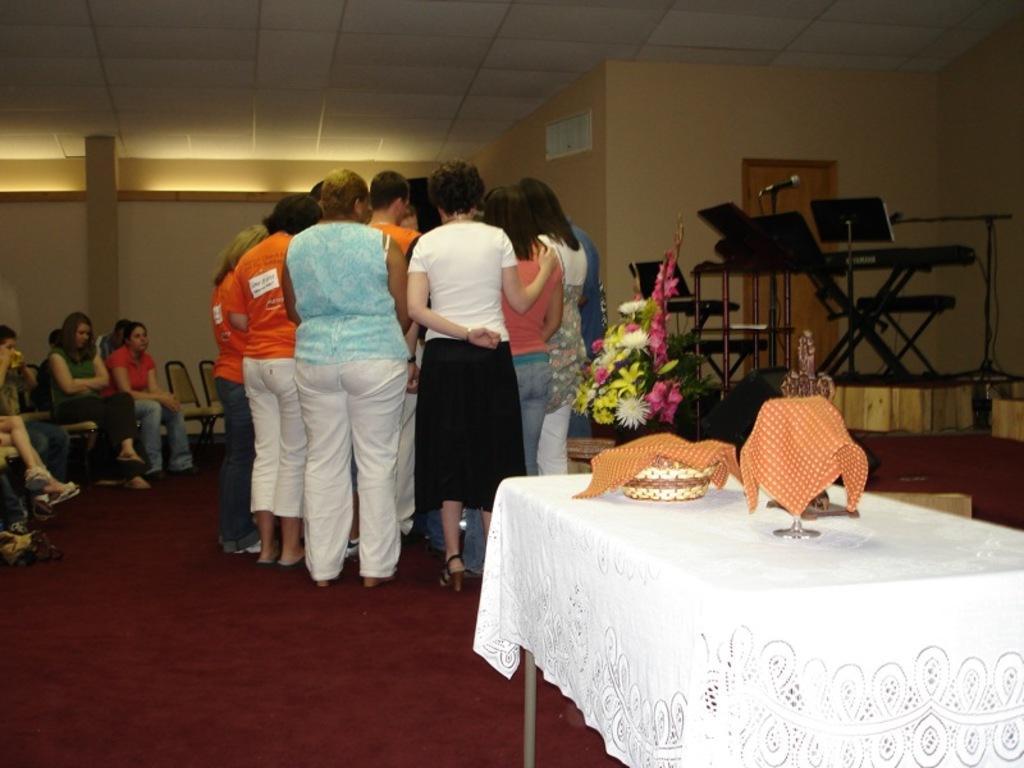Can you describe this image briefly? In this image there is a group of people standing, behind them there is a chair and a musical instrument and there is a bookey, beside that there is a table. On the table there is a basket, glass and some other objects are covered with a cloth. On the left side there are few people sat on their chairs. At the top there is a ceiling. 